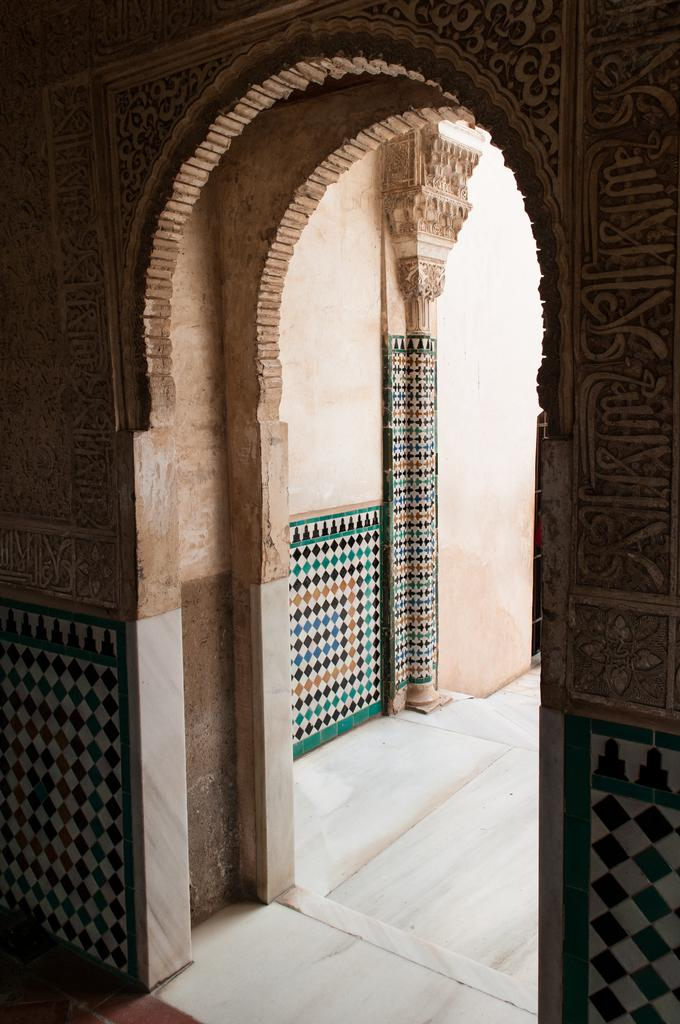What is the main subject of the image? The main subject of the image is the entrance of a building. Where was the image taken from? The image was taken from inside the building. Can you describe the view from the entrance? The view from the entrance is not visible in the image, as it was taken from inside the building. What type of trees can be seen outside the entrance in the image? There are no trees visible in the image, as it was taken from inside the building and only shows the entrance. What flavor of soda is being served at the entrance in the image? There is no soda present in the image; it only shows the entrance of the building. 